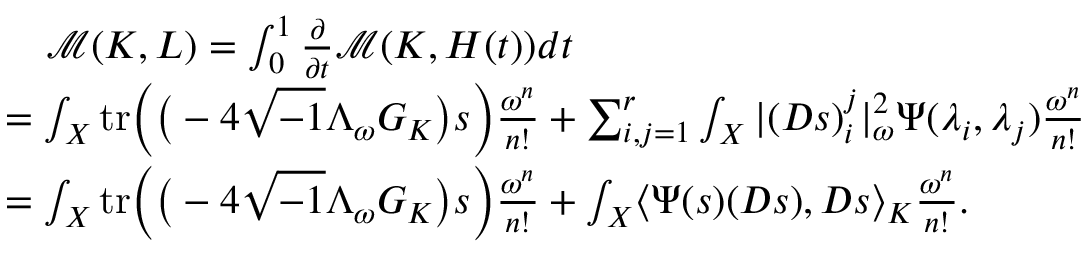Convert formula to latex. <formula><loc_0><loc_0><loc_500><loc_500>\begin{array} { r l } & { \quad \mathcal { M } ( K , L ) = \int _ { 0 } ^ { 1 } \frac { \partial } { \partial t } \mathcal { M } ( K , H ( t ) ) d t } \\ & { = \int _ { X } t r \left ( \left ( - 4 \sqrt { - 1 } \Lambda _ { \omega } G _ { K } \right ) s \right ) \frac { \omega ^ { n } } { n ! } + \sum _ { i , j = 1 } ^ { r } \int _ { X } | ( D s ) _ { i } ^ { j } | _ { \omega } ^ { 2 } \Psi ( \lambda _ { i } , \lambda _ { j } ) \frac { \omega ^ { n } } { n ! } } \\ & { = \int _ { X } t r \left ( \left ( - 4 \sqrt { - 1 } \Lambda _ { \omega } G _ { K } \right ) s \right ) \frac { \omega ^ { n } } { n ! } + \int _ { X } \langle \Psi ( s ) ( D s ) , D s \rangle _ { K } \frac { \omega ^ { n } } { n ! } . } \end{array}</formula> 